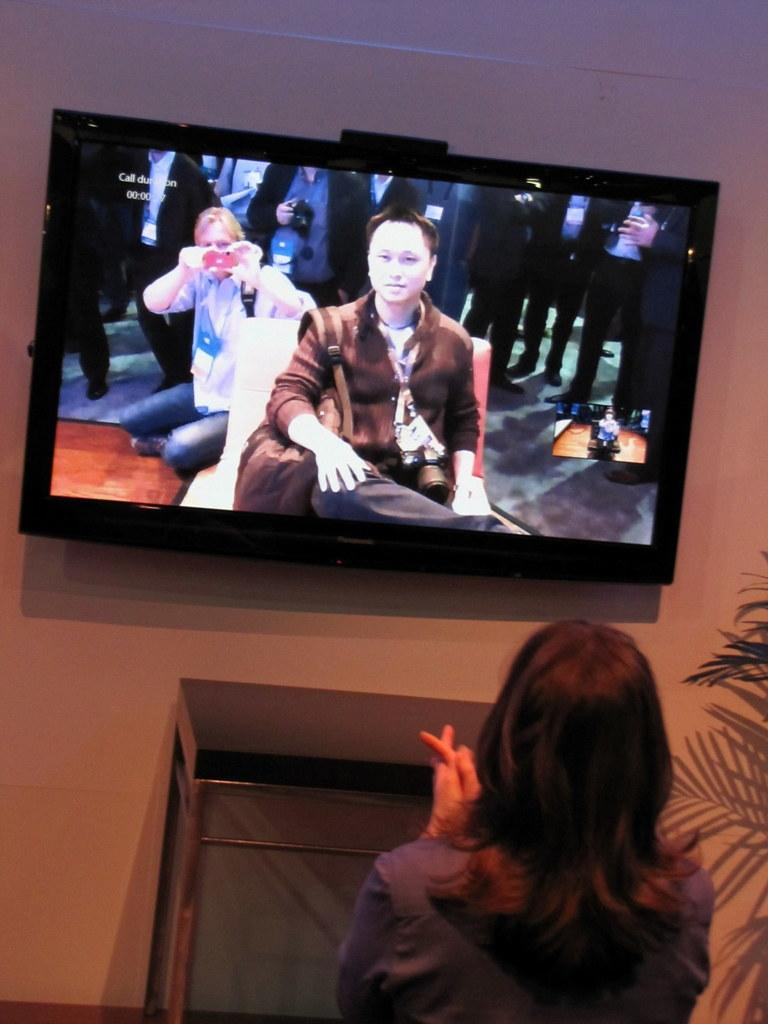Who is present in the image? There is a woman in the image. What can be seen in the background of the image? There is a plant and a table in the image. What is on the wall in the image? There is a television on the wall in the image. What is happening on the television screen? A group of people is visible on the television screen. What type of bean is being served in the cup on the table? There is no cup or bean present in the image. 